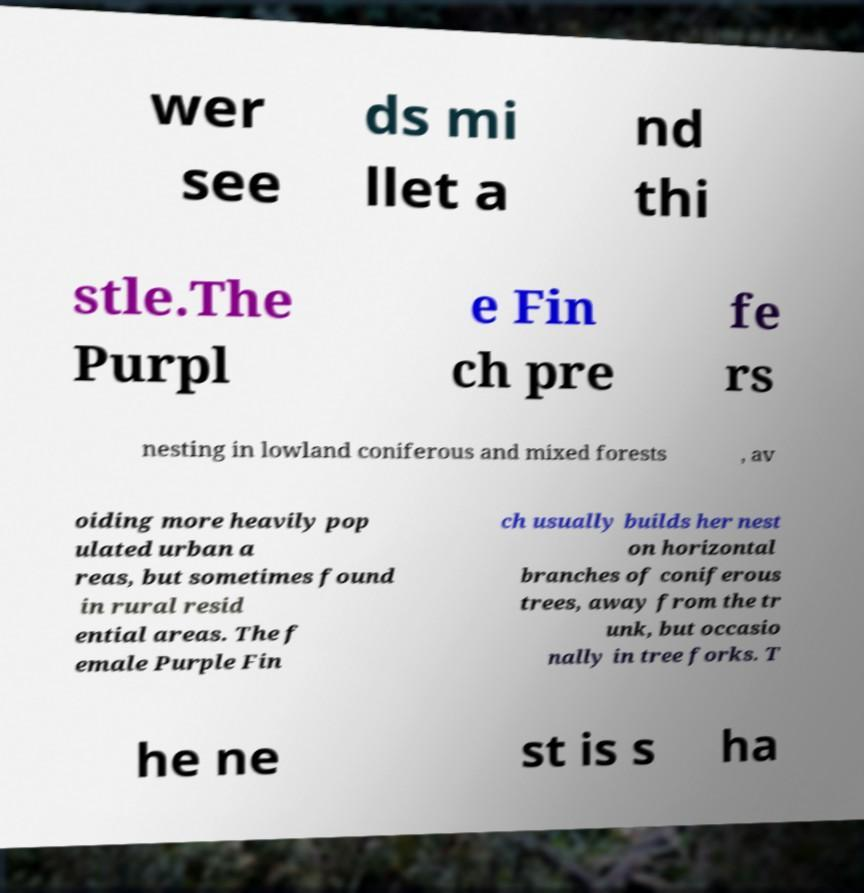What messages or text are displayed in this image? I need them in a readable, typed format. wer see ds mi llet a nd thi stle.The Purpl e Fin ch pre fe rs nesting in lowland coniferous and mixed forests , av oiding more heavily pop ulated urban a reas, but sometimes found in rural resid ential areas. The f emale Purple Fin ch usually builds her nest on horizontal branches of coniferous trees, away from the tr unk, but occasio nally in tree forks. T he ne st is s ha 